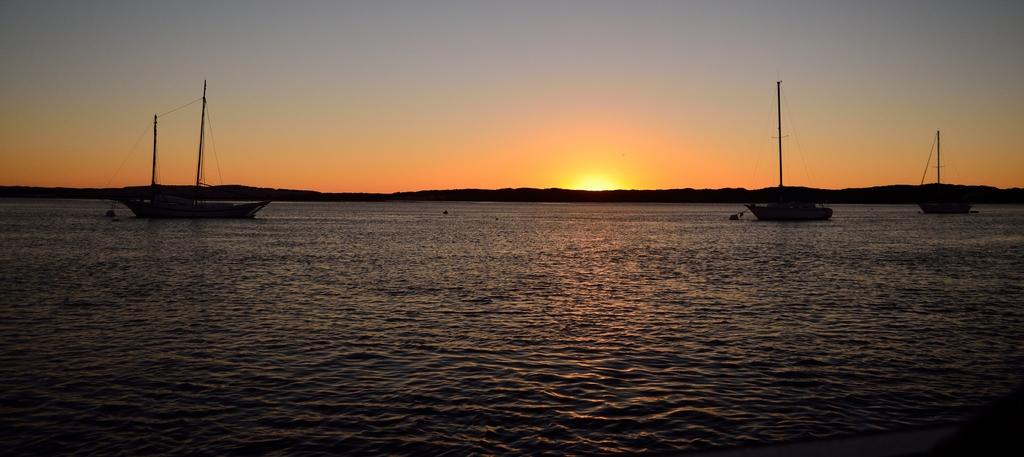What is in the foreground of the image? There is a water body in the foreground of the image. What can be seen in the water? Boats are present in the water. What type of vegetation is in the middle of the image? There are trees in the middle of the image. What is visible at the top of the image? The sky is visible at the top of the image. What is the weather like in the image? The sky is sunny, indicating a clear and bright day. Is there an island visible in the water body in the image? There is no island present in the water body in the image. What type of road can be seen connecting the trees in the image? There is no road visible in the image; only a water body, boats, trees, and the sky are present. 